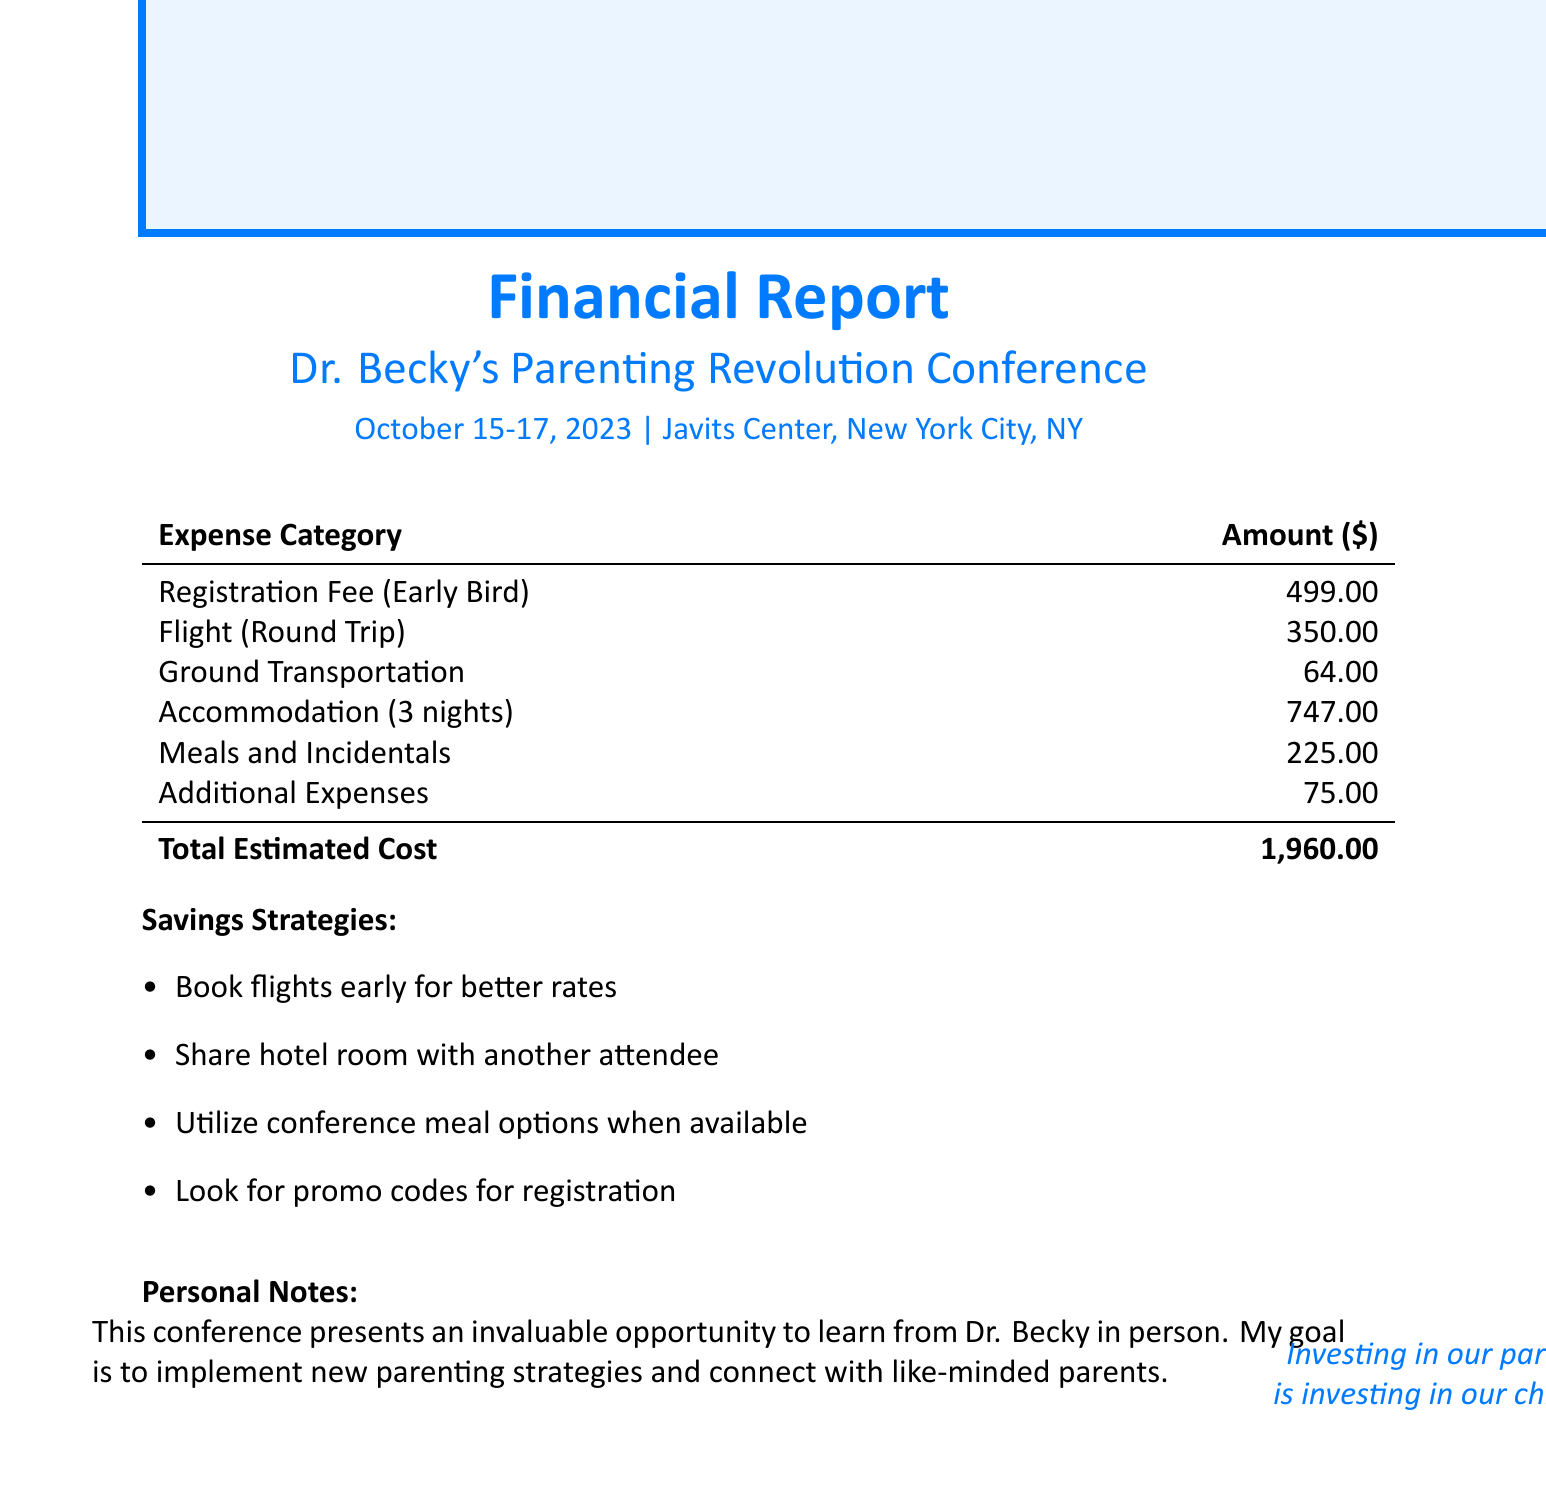What is the name of the conference? The document specifies the name of the conference as "Dr. Becky's Parenting Revolution Conference."
Answer: Dr. Becky's Parenting Revolution Conference What are the early bird registration fees? The document lists the early bird registration fee as part of the financial breakdown.
Answer: 499 What is the total lodging cost? The total lodging cost is calculated based on the nightly rate and the number of nights.
Answer: 747 What is the estimated round trip flight cost? The estimated round trip flight cost is provided in the travel costs section.
Answer: 350 How many nights will the accommodation last? The document indicates the number of nights for accommodation explicitly.
Answer: 3 What is the daily allowance for meals and incidentals? The daily allowance for meals is outlined in the meals and incidentals section.
Answer: 75 What is the total estimated cost of attending the conference? The total estimated cost is the sum of all expenses outlined in the document.
Answer: 1,960 Which hotel is recommended for accommodation? The document specifies the hotel where attendees will stay during the conference.
Answer: Hilton Midtown What are two suggested savings strategies for attending the conference? The document lists strategies to save money while attending the conference.
Answer: Book flights early for better rates, Share hotel room with another attendee What is the main goal of attending the conference? The personal notes section summarizes the objective of attending the conference.
Answer: Implement new parenting strategies and connect with like-minded parents 